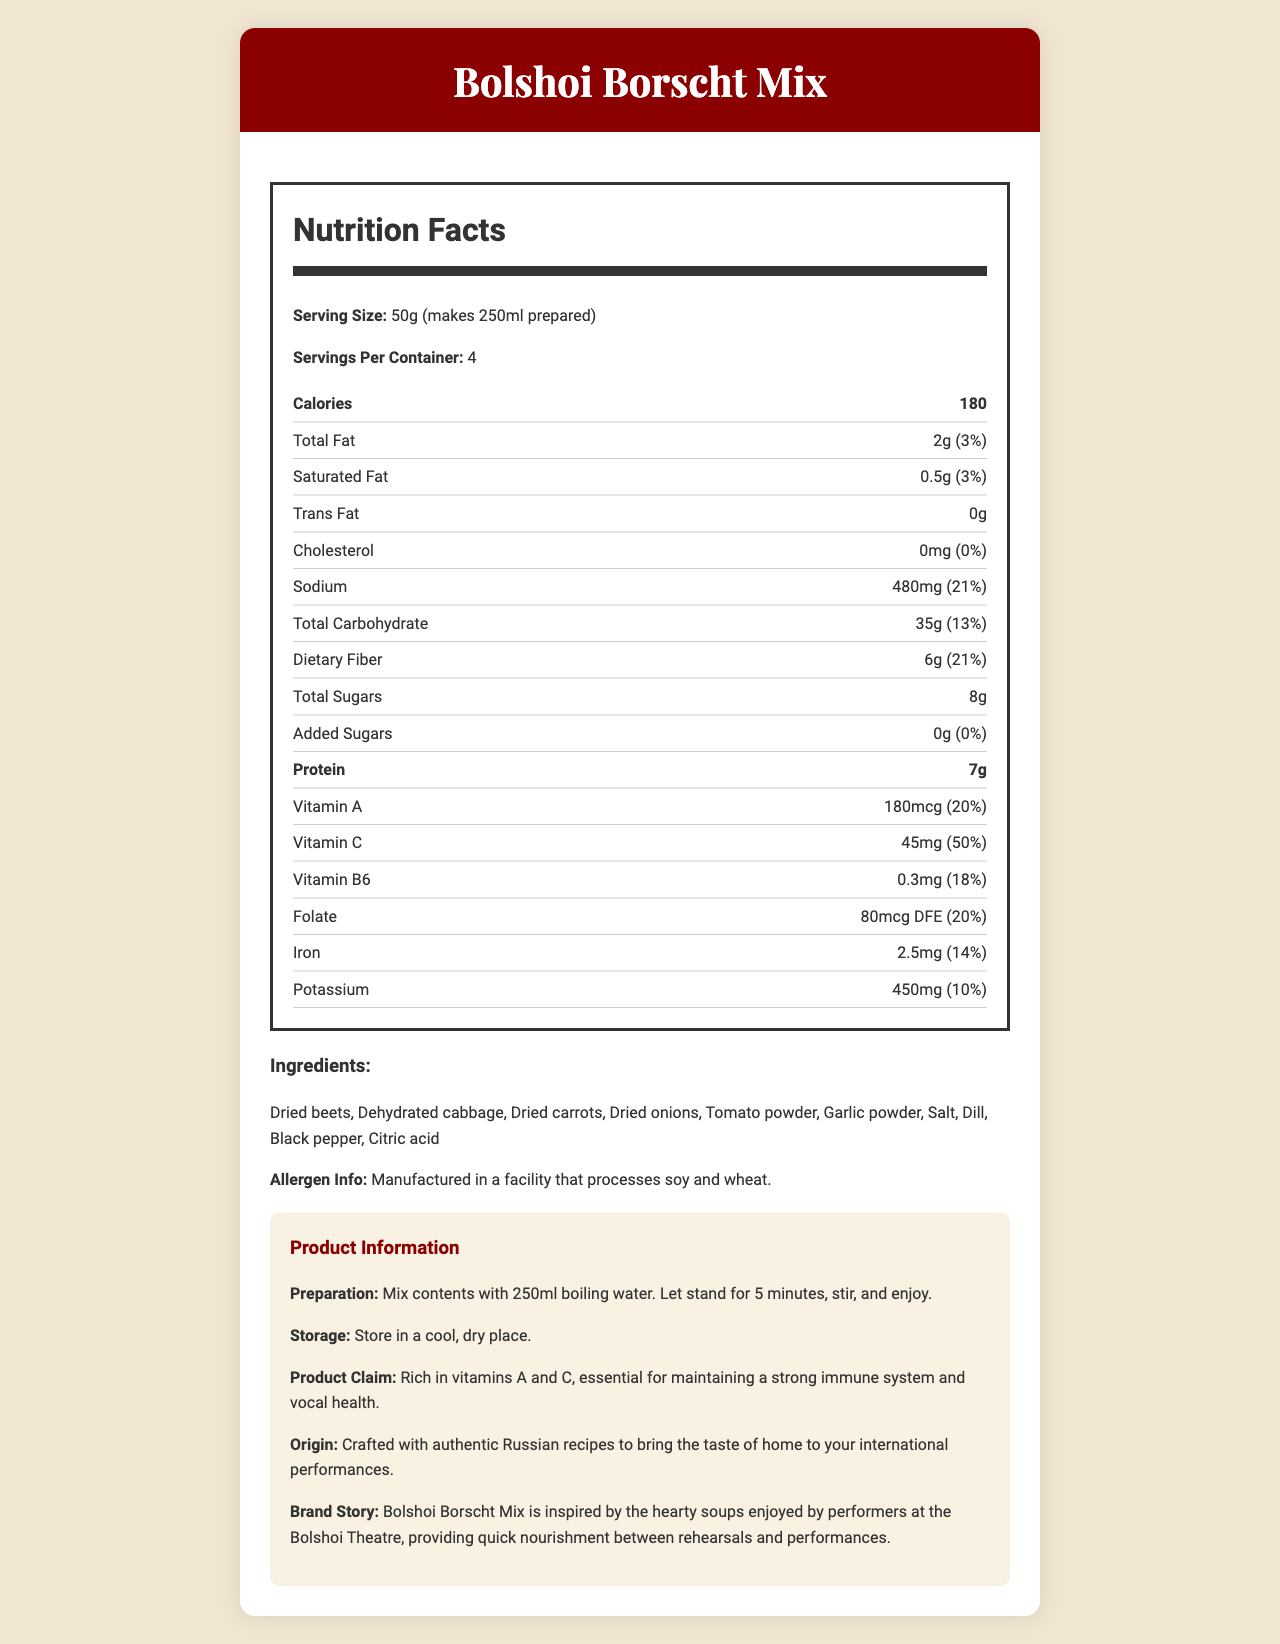what is the serving size? The serving size is mentioned at the beginning of the nutrition facts section as "50g (makes 250ml prepared)".
Answer: 50g (makes 250ml prepared) how many servings are in one container? The document states “Servings Per Container: 4” in the nutrition facts section.
Answer: 4 how many calories are in one serving of Bolshoi Borscht Mix? The document lists the calorie content as "Calories: 180" in the nutrition facts.
Answer: 180 calories what is the percentage of daily value for vitamin C in one serving? The document indicates that Vitamin C constitutes 50% of the daily value per serving.
Answer: 50% name two ingredients in the borscht mix The ingredients section lists "Dried beets" and "Dehydrated cabbage" among others.
Answer: Dried beets, Dehydrated cabbage which nutrient does not have any daily value percentage listed? A. Vitamin A B. Total Sugars C. Folate D. Sodium The total sugars amount "8g" is listed without a daily value percentage.
Answer: B how much sodium is in one serving? A. 10mg B. 100mg C. 250mg D. 480mg The sodium content is listed as "480mg" in the nutrition facts.
Answer: D is the product suitable for people with soy allergies? The document states "Manufactured in a facility that processes soy and wheat," which could pose a risk for individuals with soy allergies.
Answer: No summarize the main idea of the document The document provides an overview of the nutritional content, ingredients, and benefits of the Bolshoi Borscht Mix, emphasizing its vitamin-rich profile and Russian heritage.
Answer: Bolshoi Borscht Mix is a traditional Russian soup mix rich in vitamins A and C. The document includes detailed nutrition facts, ingredients, allergen information, and preparation instructions. It highlights the product's Russian origin and aligns it with the Bolshoi Theatre performers' nourishment need. how much protein is in the entire container? Since there are 4 servings per container and each serving has 7g of protein, the total protein is 4 x 7g = 28g.
Answer: 28g where is the Bolshoi Borscht Mix crafted? The origin section states "Crafted with authentic Russian recipes to bring the taste of home to your international performances."
Answer: Russia can the document tell you the price of the Bolshoi Borscht Mix? The document does not provide any information regarding the price of the Bolshoi Borscht Mix.
Answer: Not enough information is the Bolshoi Borscht Mix rich in fiber? The document states that each serving contains 6g of dietary fiber, which is 21% of the daily value, indicating a high fiber content.
Answer: Yes 